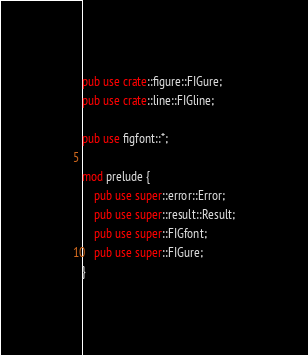Convert code to text. <code><loc_0><loc_0><loc_500><loc_500><_Rust_>pub use crate::figure::FIGure;
pub use crate::line::FIGline;

pub use figfont::*;

mod prelude {
    pub use super::error::Error;
    pub use super::result::Result;
    pub use super::FIGfont;
    pub use super::FIGure;
}
</code> 